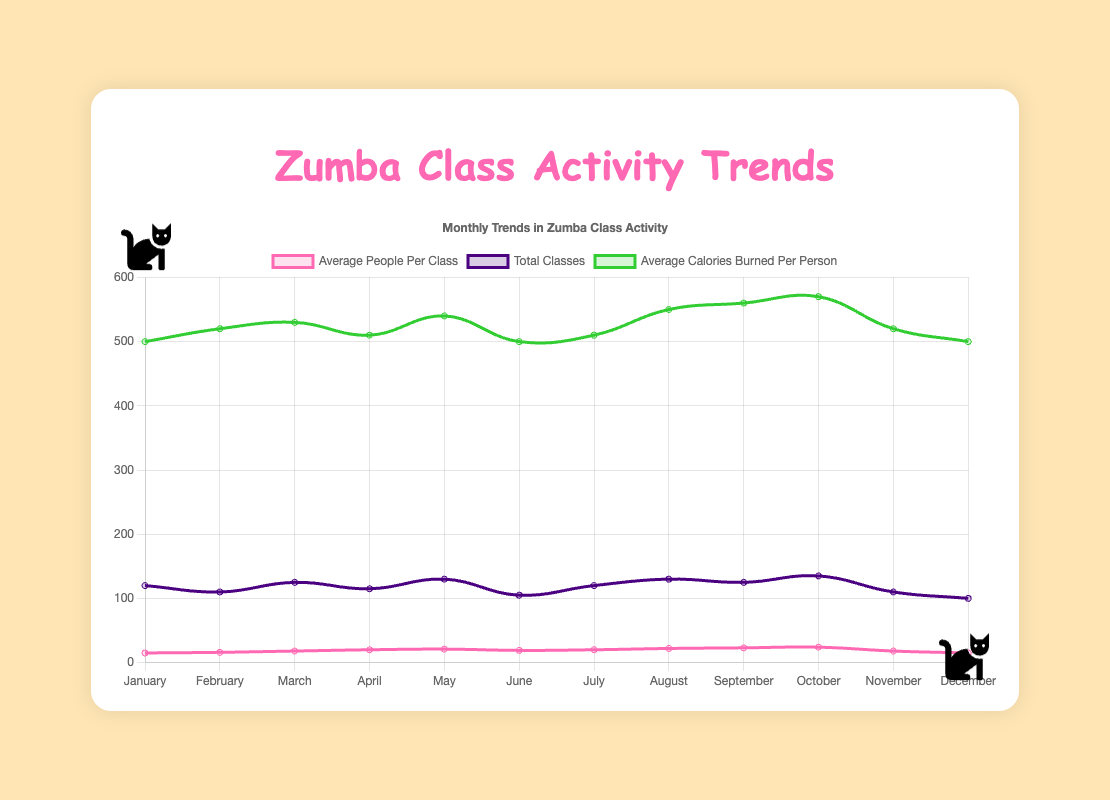What month had the highest average number of people per Zumba class? The highest point of the "Average People Per Class" curve shows the month of October with an average of 24 people per class.
Answer: October How many more average calories were burned per person in October compared to January? Average calories burned per person in October were 570, and in January, it was 500. The difference is 570 - 500 = 70 calories.
Answer: 70 Which month had the lowest total number of Zumba classes? The lowest point of the "Total Classes" curve indicates that December had the lowest total with 100 classes.
Answer: December How does the average number of people per class in July compare to August? In July, the average number of people per class was 20, while in August it increased to 22. Therefore, August had 2 more people on average per class than July.
Answer: August has 2 more What is the overall trend in the average calories burned per person from January to October? The "Average Calories Burned Per Person" curve shows a general increasing trend from 500 calories in January to 570 calories in October. This indicates a consistent increase.
Answer: Generally increasing Which months had an equal average number of people per Zumba class? Both April and July had an average of 20 people per Zumba class. This is seen by finding the points where the "Average People Per Class" curve flattens at 20.
Answer: April and July Are there any months where the total number of classes is the same? The curves for "Total Classes" in May and August both reach the same value of 130, indicating the total number of classes is the same in these months.
Answer: May and August What is the difference in total number of classes between the month with the highest and lowest total? October has the highest total classes (135), and December has the lowest (100). The difference is 135 - 100 = 35.
Answer: 35 How did the average number of people per class change from February to March? From February (16 people) to March (18 people), the average increased by 18 - 16 = 2 people per class.
Answer: Increased by 2 What color line represents the average calories burned per person? The "Average Calories Burned Per Person" is represented by a green line. This is observed by the green color curve on the chart.
Answer: Green 